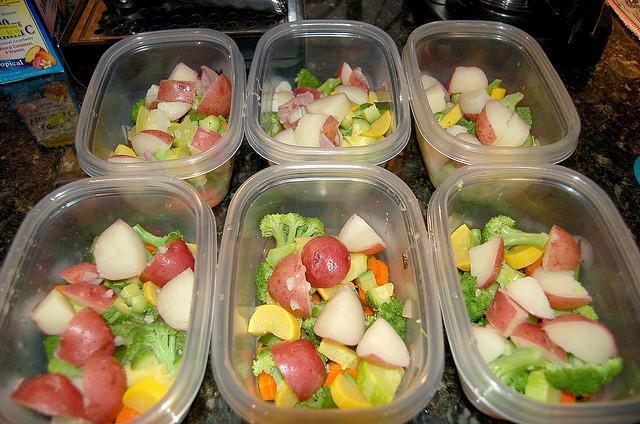How many containers are in the photo?
Give a very brief answer. 6. How many apples are in the photo?
Give a very brief answer. 6. How many bowls can be seen?
Give a very brief answer. 6. How many broccolis can you see?
Give a very brief answer. 4. 